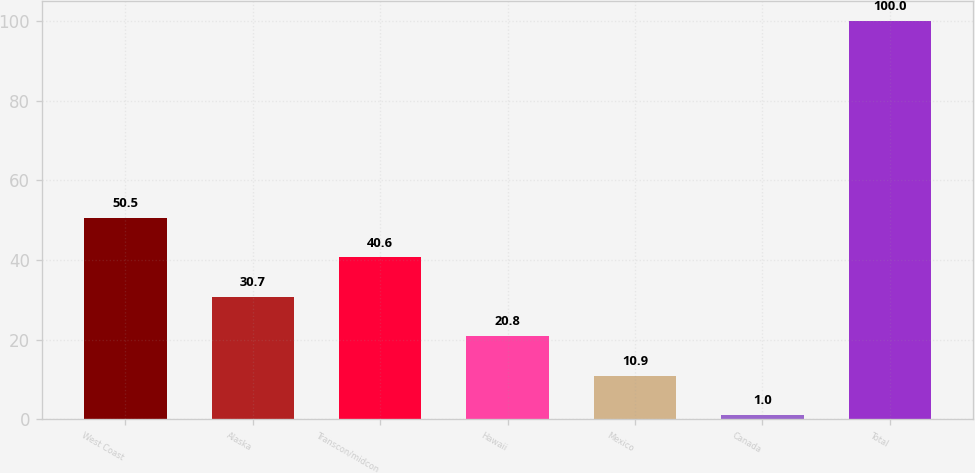<chart> <loc_0><loc_0><loc_500><loc_500><bar_chart><fcel>West Coast<fcel>Alaska<fcel>Transcon/midcon<fcel>Hawaii<fcel>Mexico<fcel>Canada<fcel>Total<nl><fcel>50.5<fcel>30.7<fcel>40.6<fcel>20.8<fcel>10.9<fcel>1<fcel>100<nl></chart> 